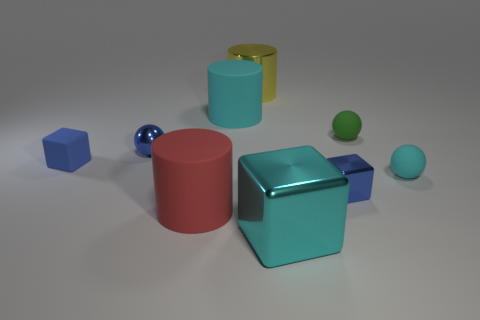Is the color of the rubber cube the same as the tiny metallic block?
Your response must be concise. Yes. How many cyan metallic objects have the same size as the cyan cube?
Your answer should be compact. 0. There is a metal object that is the same color as the metallic ball; what is its shape?
Ensure brevity in your answer.  Cube. There is a tiny matte object on the left side of the yellow shiny object; is there a small sphere that is behind it?
Make the answer very short. Yes. What number of things are tiny matte objects right of the large red rubber thing or cyan things?
Keep it short and to the point. 4. What number of tiny yellow metallic spheres are there?
Provide a succinct answer. 0. The small blue object that is made of the same material as the large red object is what shape?
Offer a very short reply. Cube. What size is the cyan rubber object behind the tiny shiny object behind the small blue matte block?
Your response must be concise. Large. What number of objects are either tiny blue blocks that are to the right of the large red rubber object or small balls to the left of the big metallic cylinder?
Offer a very short reply. 2. Is the number of brown balls less than the number of cylinders?
Your response must be concise. Yes. 